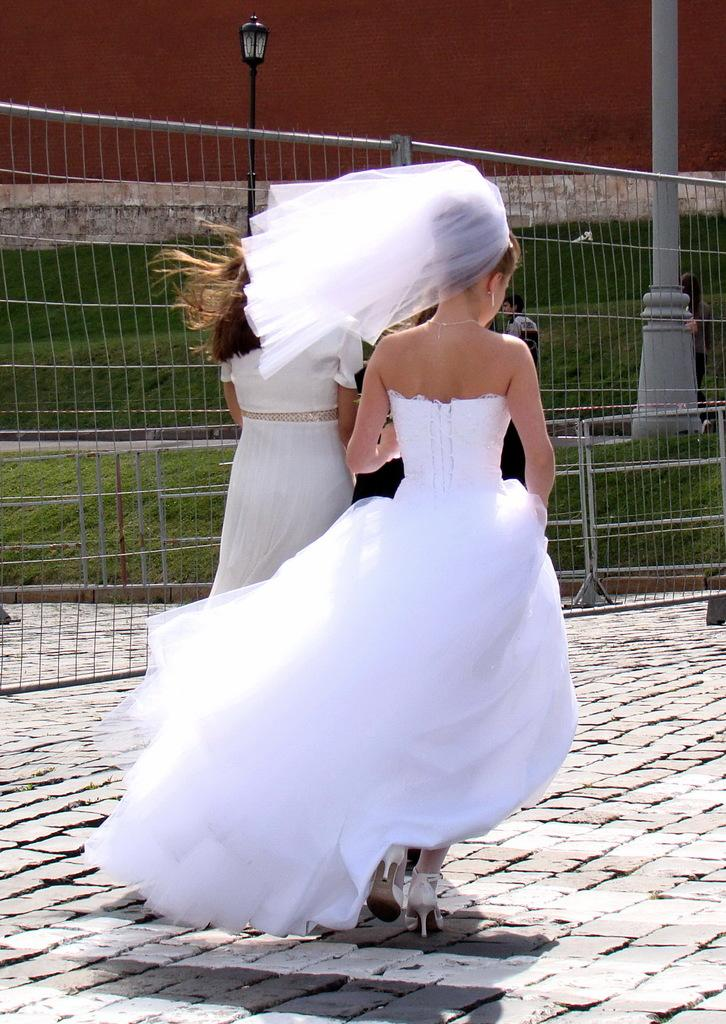How many people are in the image? There are two persons in the image. What are the persons wearing? The persons are wearing white dress. What are the persons doing in the image? The persons are walking. What can be seen in the background of the image? There is a railing, green grass, electric poles, and a brown-colored building in the background of the image. What type of ink can be seen dripping from the chicken in the image? There is no chicken present in the image, and therefore no ink can be seen dripping from it. 